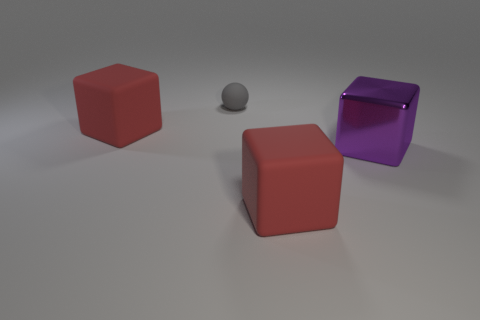Is there anything else that is the same material as the purple object?
Provide a succinct answer. No. There is a big rubber block on the left side of the tiny gray sphere; what number of big purple shiny objects are on the left side of it?
Provide a short and direct response. 0. How many other things are made of the same material as the gray ball?
Provide a succinct answer. 2. Does the big red cube that is behind the purple shiny cube have the same material as the red thing that is to the right of the small gray object?
Your answer should be compact. Yes. Is there any other thing that is the same shape as the metallic object?
Offer a very short reply. Yes. Are the gray object and the big red cube right of the small matte thing made of the same material?
Your answer should be very brief. Yes. What color is the rubber block behind the purple cube that is in front of the red matte object that is left of the small gray rubber sphere?
Provide a succinct answer. Red. Is there anything else that has the same size as the purple shiny thing?
Your answer should be very brief. Yes. Does the matte cube in front of the purple block have the same size as the red block that is on the left side of the small gray thing?
Ensure brevity in your answer.  Yes. What is the size of the thing on the left side of the gray rubber object?
Provide a short and direct response. Large. 